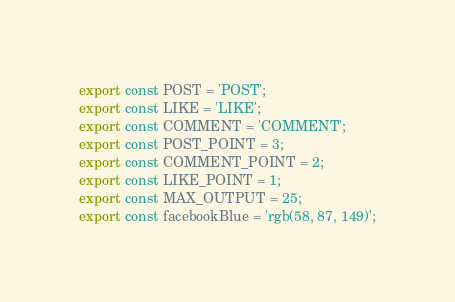Convert code to text. <code><loc_0><loc_0><loc_500><loc_500><_JavaScript_>export const POST = 'POST';
export const LIKE = 'LIKE';
export const COMMENT = 'COMMENT';
export const POST_POINT = 3;
export const COMMENT_POINT = 2;
export const LIKE_POINT = 1;
export const MAX_OUTPUT = 25;
export const facebookBlue = 'rgb(58, 87, 149)';
</code> 